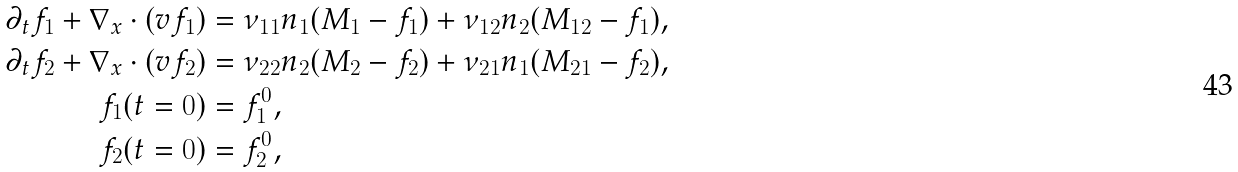Convert formula to latex. <formula><loc_0><loc_0><loc_500><loc_500>\partial _ { t } f _ { 1 } + \nabla _ { x } \cdot ( v f _ { 1 } ) & = \nu _ { 1 1 } n _ { 1 } ( M _ { 1 } - f _ { 1 } ) + \nu _ { 1 2 } n _ { 2 } ( M _ { 1 2 } - f _ { 1 } ) , \\ \partial _ { t } f _ { 2 } + \nabla _ { x } \cdot ( v f _ { 2 } ) & = \nu _ { 2 2 } n _ { 2 } ( M _ { 2 } - f _ { 2 } ) + \nu _ { 2 1 } n _ { 1 } ( M _ { 2 1 } - f _ { 2 } ) , \\ f _ { 1 } ( t = 0 ) & = f _ { 1 } ^ { 0 } , \\ f _ { 2 } ( t = 0 ) & = f _ { 2 } ^ { 0 } ,</formula> 